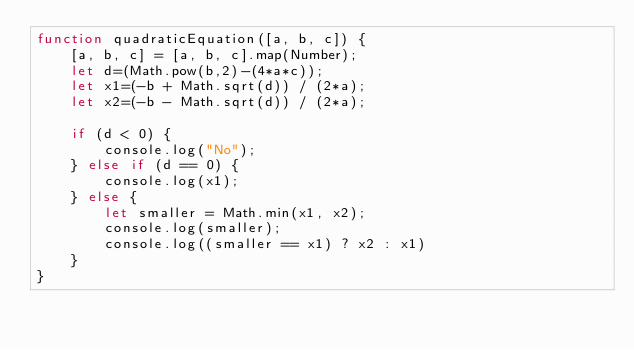Convert code to text. <code><loc_0><loc_0><loc_500><loc_500><_JavaScript_>function quadraticEquation([a, b, c]) {
    [a, b, c] = [a, b, c].map(Number);
    let d=(Math.pow(b,2)-(4*a*c));
    let x1=(-b + Math.sqrt(d)) / (2*a);
    let x2=(-b - Math.sqrt(d)) / (2*a);

    if (d < 0) {
        console.log("No");
    } else if (d == 0) {
        console.log(x1);
    } else {
        let smaller = Math.min(x1, x2);
        console.log(smaller);
        console.log((smaller == x1) ? x2 : x1)
    }
}</code> 